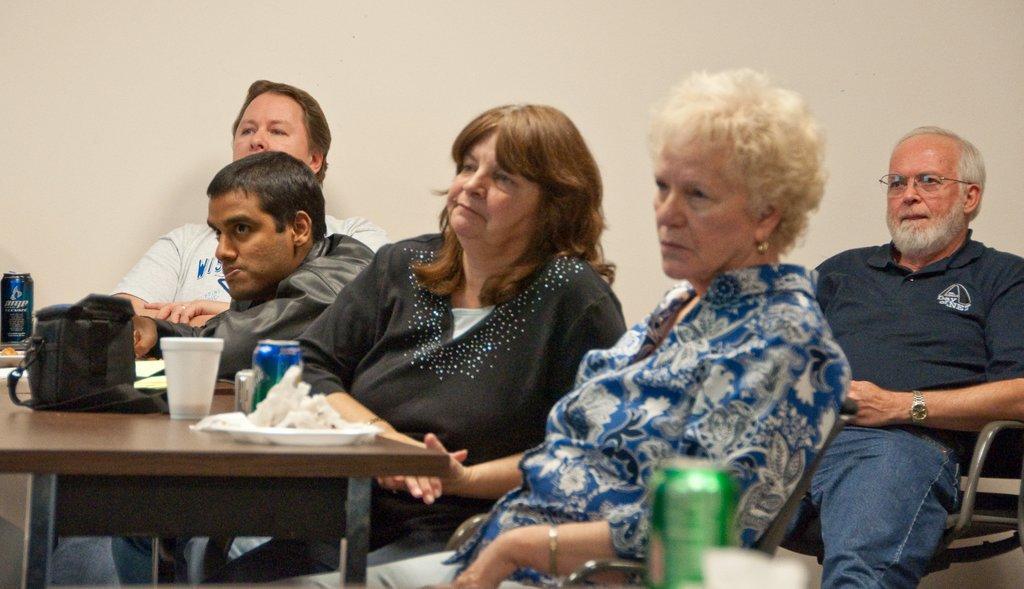Describe this image in one or two sentences. There are some people sitting in the chairs in front of the table on which plates, cups, tins, bags were placed. In the background there is a wall. 